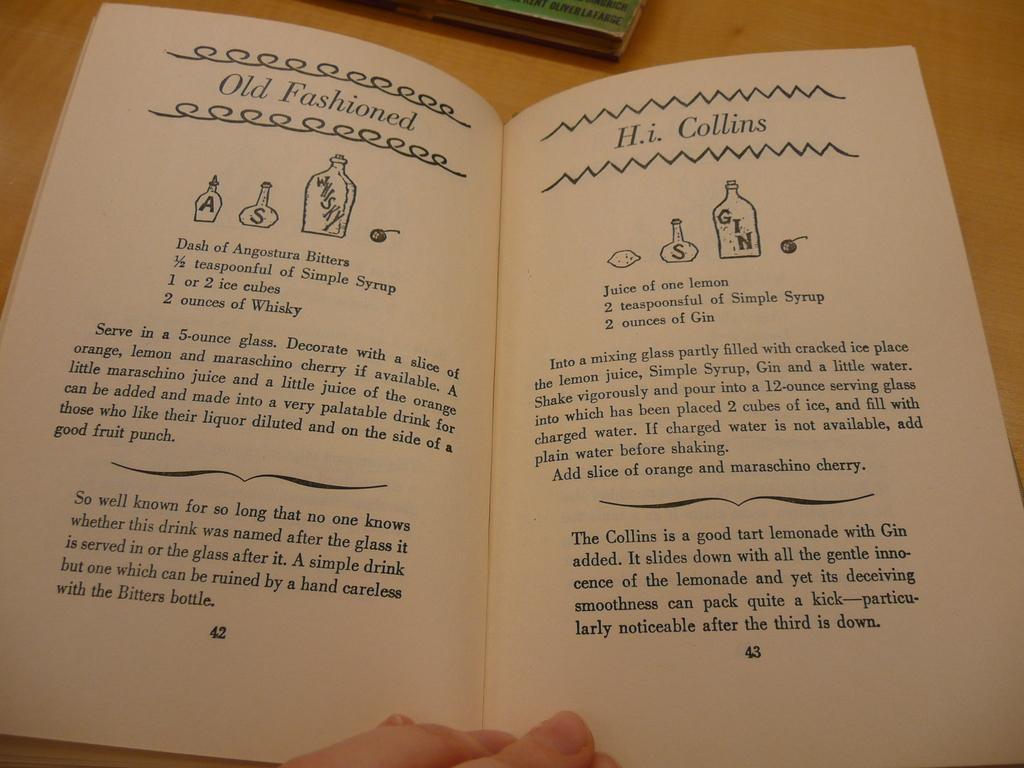<image>
Render a clear and concise summary of the photo. A recipe book is opened to page 42, which has the recipe for an Old Fashioned and page 43 with a recipe for H.i. Collins. 